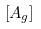<formula> <loc_0><loc_0><loc_500><loc_500>\left [ { A } _ { g } \right ]</formula> 